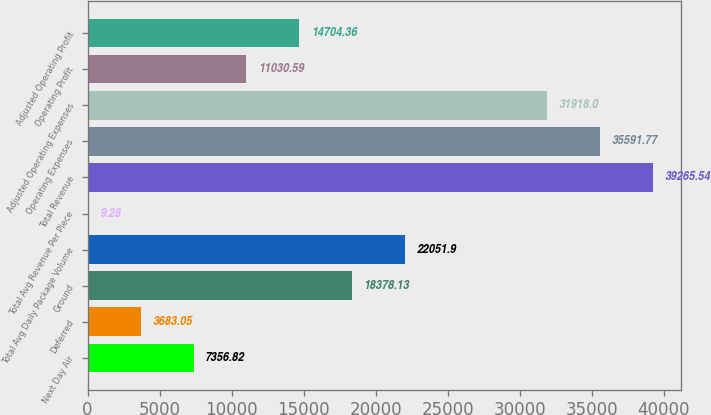Convert chart. <chart><loc_0><loc_0><loc_500><loc_500><bar_chart><fcel>Next Day Air<fcel>Deferred<fcel>Ground<fcel>Total Avg Daily Package Volume<fcel>Total Avg Revenue Per Piece<fcel>Total Revenue<fcel>Operating Expenses<fcel>Adjusted Operating Expenses<fcel>Operating Profit<fcel>Adjusted Operating Profit<nl><fcel>7356.82<fcel>3683.05<fcel>18378.1<fcel>22051.9<fcel>9.28<fcel>39265.5<fcel>35591.8<fcel>31918<fcel>11030.6<fcel>14704.4<nl></chart> 